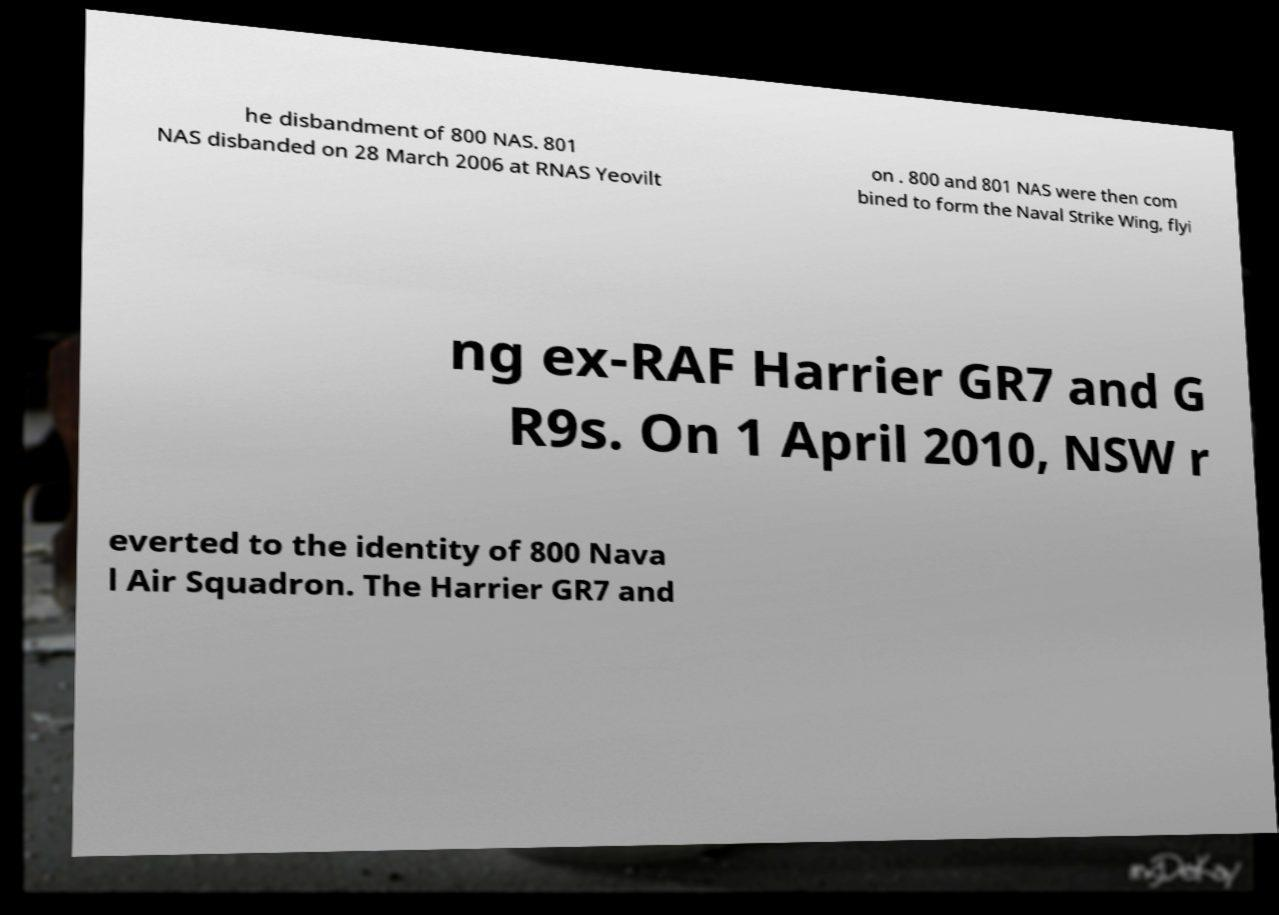Can you read and provide the text displayed in the image?This photo seems to have some interesting text. Can you extract and type it out for me? he disbandment of 800 NAS. 801 NAS disbanded on 28 March 2006 at RNAS Yeovilt on . 800 and 801 NAS were then com bined to form the Naval Strike Wing, flyi ng ex-RAF Harrier GR7 and G R9s. On 1 April 2010, NSW r everted to the identity of 800 Nava l Air Squadron. The Harrier GR7 and 